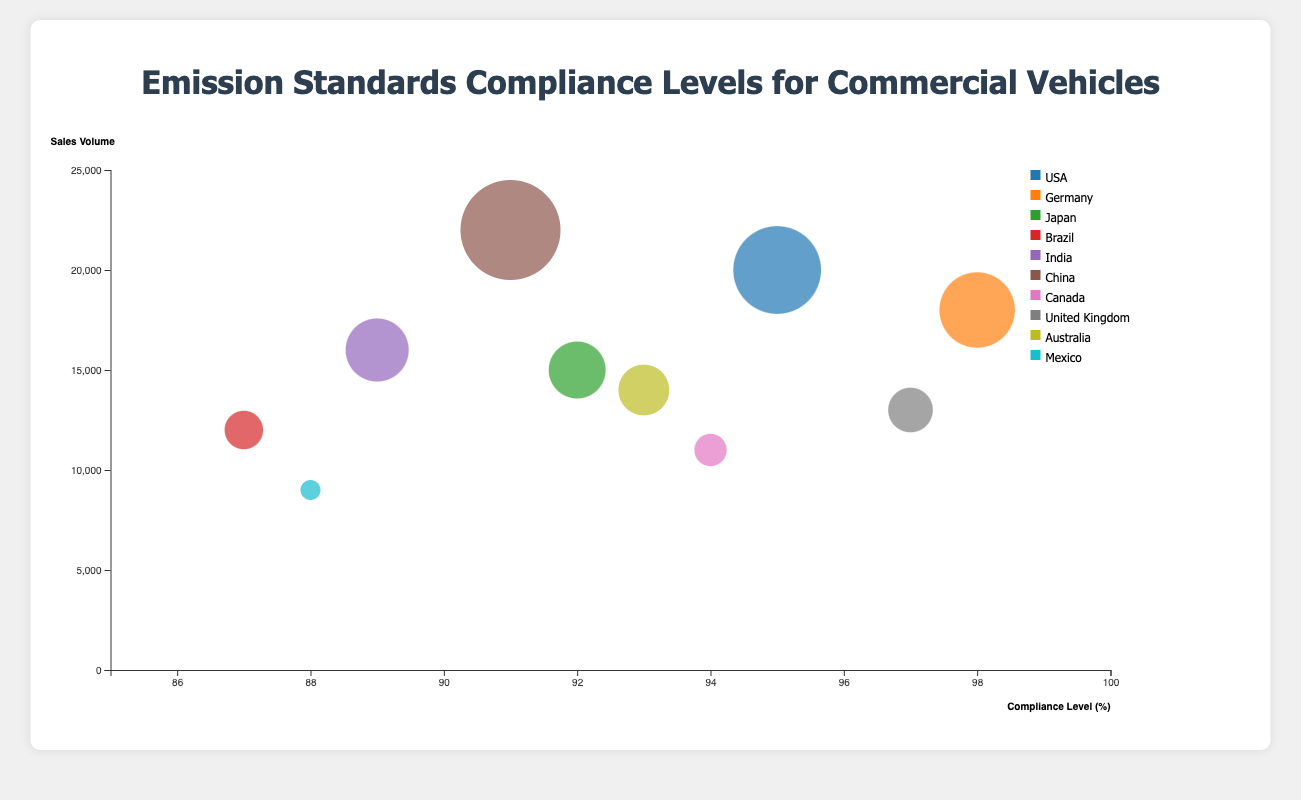What is the title of the figure? The title of the figure is usually located at the top and it summarizes the content of the chart. Here, the title is "Emission Standards Compliance Levels for Commercial Vehicles".
Answer: Emission Standards Compliance Levels for Commercial Vehicles How many commercial vehicle models are depicted in the chart? By counting each unique data point (represented by different bubbles), we find that there are 10 commercial vehicle models depicted in the chart.
Answer: 10 Which vehicle model has the highest compliance level and what is that level? By observing the position of the bubbles on the x-axis (compliance level) and identifying the one furthest to the right, we find that the Mercedes-Benz Actros has the highest compliance level of 98%.
Answer: Mercedes-Benz Actros, 98% Which country has the highest sales volume for its commercial vehicle model? By looking at the y-axis (sales volume) and identifying the bubble placed highest on the chart, we see that China, with the FAW Jiefang J6 model, has the highest sales volume of 22,000 units.
Answer: China, 22,000 Compare the compliance levels of the Freightliner Cascadia and the Tata Prima. Which has a higher compliance level? By locating the Freightliner Cascadia (USA) and Tata Prima (India) bubbles along the x-axis and comparing their x positions, we see that the Freightliner Cascadia has a compliance level of 95%, while the Tata Prima has a compliance level of 89%. Therefore, the Freightliner Cascadia has a higher compliance level.
Answer: Freightliner Cascadia What is the difference in sales volume between the Kenworth T680 and the Volkswagen Constellation? By checking the sales volume values indicated on the y-axis for the Kenworth T680 (Canada) and the Volkswagen Constellation (Brazil), we see that the Kenworth T680 has a sales volume of 11,000 units, and the Volkswagen Constellation has a sales volume of 12,000 units. The difference is 12,000 - 11,000 = 1,000 units.
Answer: 1,000 units Between the DAF XF and the Volvo FH, which model has a lower compliance level and by how much? By comparing the x positions (compliance levels) of the DAF XF (United Kingdom) and the Volvo FH (Australia), we see that the DAF XF has a compliance level of 97% and the Volvo FH has a compliance level of 93%. The difference is 97% - 93% = 4%. So, the Volvo FH has a lower compliance level by 4%.
Answer: Volvo FH by 4% What is the average compliance level for all the vehicle models depicted? To find the average compliance level, sum up the compliance levels of all models (95 + 98 + 92 + 87 + 89 + 91 + 94 + 97 + 93 + 88 = 924) and divide by the number of models (10). The average compliance level is 924 / 10 = 92.4%.
Answer: 92.4% Which vehicle model from Japan is depicted, and what are its compliance level and sales volume? By identifying the bubble color-coded for Japan and reading the associated tooltip or data label, the model is Hino 500 Series with a compliance level of 92% and a sales volume of 15,000 units.
Answer: Hino 500 Series, 92%, 15,000 units 